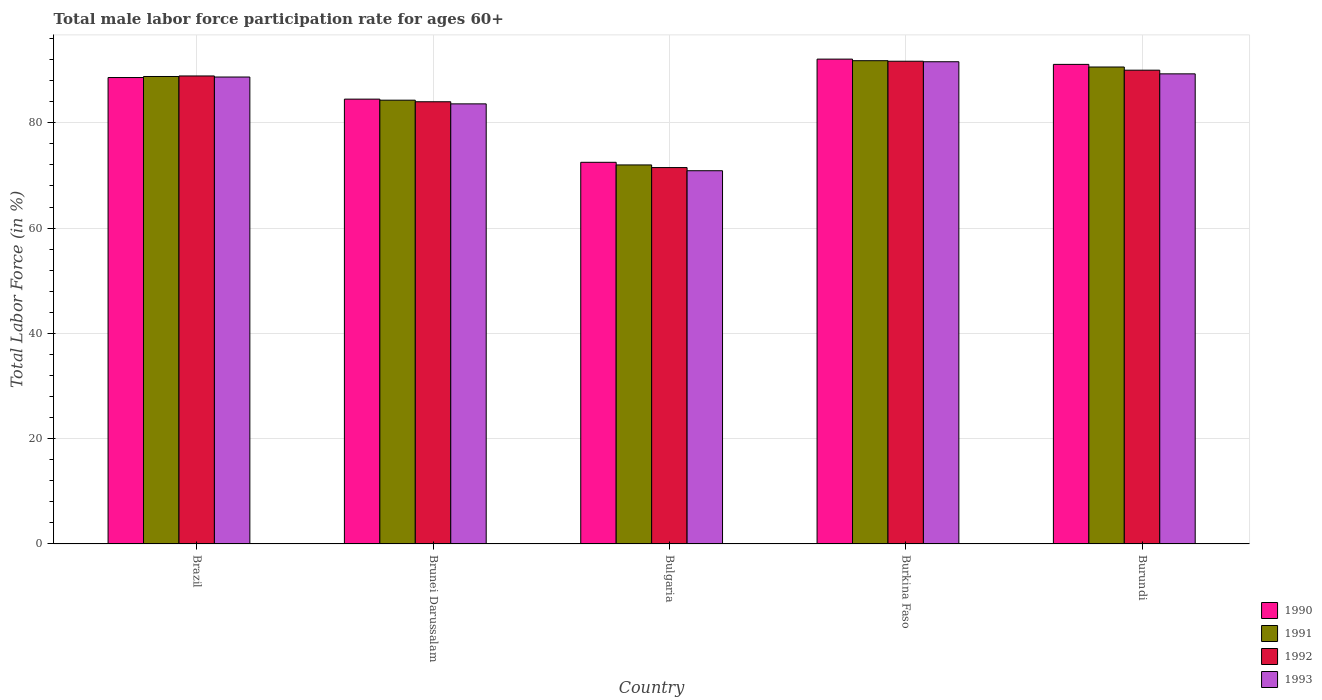How many groups of bars are there?
Make the answer very short. 5. Are the number of bars on each tick of the X-axis equal?
Offer a terse response. Yes. How many bars are there on the 2nd tick from the left?
Provide a succinct answer. 4. How many bars are there on the 2nd tick from the right?
Your response must be concise. 4. What is the label of the 2nd group of bars from the left?
Keep it short and to the point. Brunei Darussalam. In how many cases, is the number of bars for a given country not equal to the number of legend labels?
Your answer should be compact. 0. What is the male labor force participation rate in 1992 in Burundi?
Your response must be concise. 90. Across all countries, what is the maximum male labor force participation rate in 1991?
Provide a succinct answer. 91.8. Across all countries, what is the minimum male labor force participation rate in 1993?
Your answer should be very brief. 70.9. In which country was the male labor force participation rate in 1991 maximum?
Give a very brief answer. Burkina Faso. In which country was the male labor force participation rate in 1990 minimum?
Ensure brevity in your answer.  Bulgaria. What is the total male labor force participation rate in 1990 in the graph?
Give a very brief answer. 428.8. What is the difference between the male labor force participation rate in 1992 in Brazil and that in Bulgaria?
Give a very brief answer. 17.4. What is the difference between the male labor force participation rate in 1991 in Bulgaria and the male labor force participation rate in 1993 in Burkina Faso?
Your answer should be compact. -19.6. What is the average male labor force participation rate in 1991 per country?
Make the answer very short. 85.5. What is the difference between the male labor force participation rate of/in 1991 and male labor force participation rate of/in 1993 in Brunei Darussalam?
Make the answer very short. 0.7. In how many countries, is the male labor force participation rate in 1993 greater than 88 %?
Your response must be concise. 3. What is the ratio of the male labor force participation rate in 1993 in Bulgaria to that in Burkina Faso?
Make the answer very short. 0.77. Is the male labor force participation rate in 1993 in Brunei Darussalam less than that in Burundi?
Your answer should be very brief. Yes. Is the difference between the male labor force participation rate in 1991 in Burkina Faso and Burundi greater than the difference between the male labor force participation rate in 1993 in Burkina Faso and Burundi?
Ensure brevity in your answer.  No. What is the difference between the highest and the second highest male labor force participation rate in 1991?
Provide a succinct answer. -1.8. What is the difference between the highest and the lowest male labor force participation rate in 1993?
Make the answer very short. 20.7. In how many countries, is the male labor force participation rate in 1992 greater than the average male labor force participation rate in 1992 taken over all countries?
Your answer should be compact. 3. Is it the case that in every country, the sum of the male labor force participation rate in 1993 and male labor force participation rate in 1990 is greater than the sum of male labor force participation rate in 1991 and male labor force participation rate in 1992?
Ensure brevity in your answer.  No. What does the 1st bar from the left in Burkina Faso represents?
Offer a terse response. 1990. Does the graph contain grids?
Make the answer very short. Yes. How many legend labels are there?
Ensure brevity in your answer.  4. How are the legend labels stacked?
Offer a very short reply. Vertical. What is the title of the graph?
Offer a very short reply. Total male labor force participation rate for ages 60+. What is the label or title of the Y-axis?
Give a very brief answer. Total Labor Force (in %). What is the Total Labor Force (in %) in 1990 in Brazil?
Your answer should be compact. 88.6. What is the Total Labor Force (in %) in 1991 in Brazil?
Your answer should be very brief. 88.8. What is the Total Labor Force (in %) of 1992 in Brazil?
Your answer should be very brief. 88.9. What is the Total Labor Force (in %) in 1993 in Brazil?
Ensure brevity in your answer.  88.7. What is the Total Labor Force (in %) in 1990 in Brunei Darussalam?
Provide a short and direct response. 84.5. What is the Total Labor Force (in %) of 1991 in Brunei Darussalam?
Provide a succinct answer. 84.3. What is the Total Labor Force (in %) in 1993 in Brunei Darussalam?
Make the answer very short. 83.6. What is the Total Labor Force (in %) of 1990 in Bulgaria?
Your answer should be very brief. 72.5. What is the Total Labor Force (in %) of 1991 in Bulgaria?
Your answer should be very brief. 72. What is the Total Labor Force (in %) of 1992 in Bulgaria?
Make the answer very short. 71.5. What is the Total Labor Force (in %) of 1993 in Bulgaria?
Your answer should be very brief. 70.9. What is the Total Labor Force (in %) in 1990 in Burkina Faso?
Your response must be concise. 92.1. What is the Total Labor Force (in %) in 1991 in Burkina Faso?
Offer a very short reply. 91.8. What is the Total Labor Force (in %) of 1992 in Burkina Faso?
Make the answer very short. 91.7. What is the Total Labor Force (in %) in 1993 in Burkina Faso?
Ensure brevity in your answer.  91.6. What is the Total Labor Force (in %) in 1990 in Burundi?
Make the answer very short. 91.1. What is the Total Labor Force (in %) in 1991 in Burundi?
Your answer should be very brief. 90.6. What is the Total Labor Force (in %) of 1992 in Burundi?
Give a very brief answer. 90. What is the Total Labor Force (in %) in 1993 in Burundi?
Provide a short and direct response. 89.3. Across all countries, what is the maximum Total Labor Force (in %) in 1990?
Offer a terse response. 92.1. Across all countries, what is the maximum Total Labor Force (in %) in 1991?
Your answer should be very brief. 91.8. Across all countries, what is the maximum Total Labor Force (in %) in 1992?
Provide a short and direct response. 91.7. Across all countries, what is the maximum Total Labor Force (in %) of 1993?
Give a very brief answer. 91.6. Across all countries, what is the minimum Total Labor Force (in %) in 1990?
Provide a succinct answer. 72.5. Across all countries, what is the minimum Total Labor Force (in %) in 1992?
Offer a terse response. 71.5. Across all countries, what is the minimum Total Labor Force (in %) of 1993?
Offer a terse response. 70.9. What is the total Total Labor Force (in %) in 1990 in the graph?
Your answer should be compact. 428.8. What is the total Total Labor Force (in %) of 1991 in the graph?
Make the answer very short. 427.5. What is the total Total Labor Force (in %) in 1992 in the graph?
Your answer should be compact. 426.1. What is the total Total Labor Force (in %) in 1993 in the graph?
Your answer should be compact. 424.1. What is the difference between the Total Labor Force (in %) in 1990 in Brazil and that in Brunei Darussalam?
Offer a very short reply. 4.1. What is the difference between the Total Labor Force (in %) of 1992 in Brazil and that in Brunei Darussalam?
Offer a terse response. 4.9. What is the difference between the Total Labor Force (in %) in 1991 in Brazil and that in Bulgaria?
Ensure brevity in your answer.  16.8. What is the difference between the Total Labor Force (in %) in 1992 in Brazil and that in Bulgaria?
Keep it short and to the point. 17.4. What is the difference between the Total Labor Force (in %) in 1990 in Brazil and that in Burundi?
Your response must be concise. -2.5. What is the difference between the Total Labor Force (in %) in 1991 in Brazil and that in Burundi?
Offer a very short reply. -1.8. What is the difference between the Total Labor Force (in %) of 1992 in Brazil and that in Burundi?
Provide a succinct answer. -1.1. What is the difference between the Total Labor Force (in %) in 1993 in Brazil and that in Burundi?
Offer a terse response. -0.6. What is the difference between the Total Labor Force (in %) of 1992 in Brunei Darussalam and that in Bulgaria?
Offer a terse response. 12.5. What is the difference between the Total Labor Force (in %) in 1992 in Brunei Darussalam and that in Burundi?
Your answer should be compact. -6. What is the difference between the Total Labor Force (in %) of 1990 in Bulgaria and that in Burkina Faso?
Keep it short and to the point. -19.6. What is the difference between the Total Labor Force (in %) of 1991 in Bulgaria and that in Burkina Faso?
Your answer should be compact. -19.8. What is the difference between the Total Labor Force (in %) in 1992 in Bulgaria and that in Burkina Faso?
Your response must be concise. -20.2. What is the difference between the Total Labor Force (in %) of 1993 in Bulgaria and that in Burkina Faso?
Your answer should be compact. -20.7. What is the difference between the Total Labor Force (in %) in 1990 in Bulgaria and that in Burundi?
Your answer should be very brief. -18.6. What is the difference between the Total Labor Force (in %) in 1991 in Bulgaria and that in Burundi?
Offer a very short reply. -18.6. What is the difference between the Total Labor Force (in %) in 1992 in Bulgaria and that in Burundi?
Offer a terse response. -18.5. What is the difference between the Total Labor Force (in %) of 1993 in Bulgaria and that in Burundi?
Your response must be concise. -18.4. What is the difference between the Total Labor Force (in %) of 1990 in Burkina Faso and that in Burundi?
Your response must be concise. 1. What is the difference between the Total Labor Force (in %) of 1991 in Burkina Faso and that in Burundi?
Your response must be concise. 1.2. What is the difference between the Total Labor Force (in %) in 1990 in Brazil and the Total Labor Force (in %) in 1993 in Brunei Darussalam?
Make the answer very short. 5. What is the difference between the Total Labor Force (in %) in 1991 in Brazil and the Total Labor Force (in %) in 1992 in Brunei Darussalam?
Offer a very short reply. 4.8. What is the difference between the Total Labor Force (in %) in 1991 in Brazil and the Total Labor Force (in %) in 1993 in Brunei Darussalam?
Make the answer very short. 5.2. What is the difference between the Total Labor Force (in %) in 1991 in Brazil and the Total Labor Force (in %) in 1992 in Bulgaria?
Your response must be concise. 17.3. What is the difference between the Total Labor Force (in %) in 1990 in Brazil and the Total Labor Force (in %) in 1993 in Burkina Faso?
Ensure brevity in your answer.  -3. What is the difference between the Total Labor Force (in %) of 1992 in Brazil and the Total Labor Force (in %) of 1993 in Burkina Faso?
Make the answer very short. -2.7. What is the difference between the Total Labor Force (in %) of 1990 in Brazil and the Total Labor Force (in %) of 1991 in Burundi?
Your answer should be compact. -2. What is the difference between the Total Labor Force (in %) in 1992 in Brazil and the Total Labor Force (in %) in 1993 in Burundi?
Offer a very short reply. -0.4. What is the difference between the Total Labor Force (in %) in 1990 in Brunei Darussalam and the Total Labor Force (in %) in 1991 in Bulgaria?
Make the answer very short. 12.5. What is the difference between the Total Labor Force (in %) in 1990 in Brunei Darussalam and the Total Labor Force (in %) in 1993 in Bulgaria?
Make the answer very short. 13.6. What is the difference between the Total Labor Force (in %) of 1991 in Brunei Darussalam and the Total Labor Force (in %) of 1993 in Bulgaria?
Provide a succinct answer. 13.4. What is the difference between the Total Labor Force (in %) in 1990 in Brunei Darussalam and the Total Labor Force (in %) in 1991 in Burkina Faso?
Your answer should be compact. -7.3. What is the difference between the Total Labor Force (in %) of 1991 in Brunei Darussalam and the Total Labor Force (in %) of 1992 in Burkina Faso?
Make the answer very short. -7.4. What is the difference between the Total Labor Force (in %) of 1991 in Brunei Darussalam and the Total Labor Force (in %) of 1993 in Burkina Faso?
Provide a short and direct response. -7.3. What is the difference between the Total Labor Force (in %) in 1992 in Brunei Darussalam and the Total Labor Force (in %) in 1993 in Burkina Faso?
Provide a short and direct response. -7.6. What is the difference between the Total Labor Force (in %) in 1990 in Brunei Darussalam and the Total Labor Force (in %) in 1991 in Burundi?
Ensure brevity in your answer.  -6.1. What is the difference between the Total Labor Force (in %) in 1990 in Brunei Darussalam and the Total Labor Force (in %) in 1993 in Burundi?
Give a very brief answer. -4.8. What is the difference between the Total Labor Force (in %) of 1991 in Brunei Darussalam and the Total Labor Force (in %) of 1992 in Burundi?
Give a very brief answer. -5.7. What is the difference between the Total Labor Force (in %) of 1991 in Brunei Darussalam and the Total Labor Force (in %) of 1993 in Burundi?
Your answer should be very brief. -5. What is the difference between the Total Labor Force (in %) in 1992 in Brunei Darussalam and the Total Labor Force (in %) in 1993 in Burundi?
Keep it short and to the point. -5.3. What is the difference between the Total Labor Force (in %) of 1990 in Bulgaria and the Total Labor Force (in %) of 1991 in Burkina Faso?
Give a very brief answer. -19.3. What is the difference between the Total Labor Force (in %) of 1990 in Bulgaria and the Total Labor Force (in %) of 1992 in Burkina Faso?
Offer a very short reply. -19.2. What is the difference between the Total Labor Force (in %) in 1990 in Bulgaria and the Total Labor Force (in %) in 1993 in Burkina Faso?
Your answer should be compact. -19.1. What is the difference between the Total Labor Force (in %) of 1991 in Bulgaria and the Total Labor Force (in %) of 1992 in Burkina Faso?
Your answer should be very brief. -19.7. What is the difference between the Total Labor Force (in %) of 1991 in Bulgaria and the Total Labor Force (in %) of 1993 in Burkina Faso?
Ensure brevity in your answer.  -19.6. What is the difference between the Total Labor Force (in %) in 1992 in Bulgaria and the Total Labor Force (in %) in 1993 in Burkina Faso?
Make the answer very short. -20.1. What is the difference between the Total Labor Force (in %) of 1990 in Bulgaria and the Total Labor Force (in %) of 1991 in Burundi?
Provide a short and direct response. -18.1. What is the difference between the Total Labor Force (in %) in 1990 in Bulgaria and the Total Labor Force (in %) in 1992 in Burundi?
Your answer should be very brief. -17.5. What is the difference between the Total Labor Force (in %) in 1990 in Bulgaria and the Total Labor Force (in %) in 1993 in Burundi?
Offer a terse response. -16.8. What is the difference between the Total Labor Force (in %) in 1991 in Bulgaria and the Total Labor Force (in %) in 1992 in Burundi?
Your response must be concise. -18. What is the difference between the Total Labor Force (in %) in 1991 in Bulgaria and the Total Labor Force (in %) in 1993 in Burundi?
Keep it short and to the point. -17.3. What is the difference between the Total Labor Force (in %) in 1992 in Bulgaria and the Total Labor Force (in %) in 1993 in Burundi?
Ensure brevity in your answer.  -17.8. What is the difference between the Total Labor Force (in %) in 1990 in Burkina Faso and the Total Labor Force (in %) in 1991 in Burundi?
Offer a very short reply. 1.5. What is the difference between the Total Labor Force (in %) of 1990 in Burkina Faso and the Total Labor Force (in %) of 1993 in Burundi?
Make the answer very short. 2.8. What is the difference between the Total Labor Force (in %) of 1992 in Burkina Faso and the Total Labor Force (in %) of 1993 in Burundi?
Your answer should be very brief. 2.4. What is the average Total Labor Force (in %) of 1990 per country?
Ensure brevity in your answer.  85.76. What is the average Total Labor Force (in %) of 1991 per country?
Offer a terse response. 85.5. What is the average Total Labor Force (in %) of 1992 per country?
Provide a short and direct response. 85.22. What is the average Total Labor Force (in %) of 1993 per country?
Provide a succinct answer. 84.82. What is the difference between the Total Labor Force (in %) in 1990 and Total Labor Force (in %) in 1991 in Brazil?
Give a very brief answer. -0.2. What is the difference between the Total Labor Force (in %) of 1990 and Total Labor Force (in %) of 1993 in Brazil?
Keep it short and to the point. -0.1. What is the difference between the Total Labor Force (in %) in 1992 and Total Labor Force (in %) in 1993 in Brazil?
Make the answer very short. 0.2. What is the difference between the Total Labor Force (in %) of 1990 and Total Labor Force (in %) of 1993 in Brunei Darussalam?
Offer a very short reply. 0.9. What is the difference between the Total Labor Force (in %) in 1992 and Total Labor Force (in %) in 1993 in Brunei Darussalam?
Provide a short and direct response. 0.4. What is the difference between the Total Labor Force (in %) of 1990 and Total Labor Force (in %) of 1993 in Bulgaria?
Offer a very short reply. 1.6. What is the difference between the Total Labor Force (in %) in 1990 and Total Labor Force (in %) in 1993 in Burkina Faso?
Offer a very short reply. 0.5. What is the difference between the Total Labor Force (in %) in 1991 and Total Labor Force (in %) in 1992 in Burkina Faso?
Your answer should be compact. 0.1. What is the difference between the Total Labor Force (in %) of 1991 and Total Labor Force (in %) of 1993 in Burkina Faso?
Your answer should be very brief. 0.2. What is the difference between the Total Labor Force (in %) in 1991 and Total Labor Force (in %) in 1993 in Burundi?
Ensure brevity in your answer.  1.3. What is the difference between the Total Labor Force (in %) of 1992 and Total Labor Force (in %) of 1993 in Burundi?
Make the answer very short. 0.7. What is the ratio of the Total Labor Force (in %) of 1990 in Brazil to that in Brunei Darussalam?
Give a very brief answer. 1.05. What is the ratio of the Total Labor Force (in %) in 1991 in Brazil to that in Brunei Darussalam?
Give a very brief answer. 1.05. What is the ratio of the Total Labor Force (in %) in 1992 in Brazil to that in Brunei Darussalam?
Your answer should be compact. 1.06. What is the ratio of the Total Labor Force (in %) in 1993 in Brazil to that in Brunei Darussalam?
Your answer should be very brief. 1.06. What is the ratio of the Total Labor Force (in %) of 1990 in Brazil to that in Bulgaria?
Offer a terse response. 1.22. What is the ratio of the Total Labor Force (in %) of 1991 in Brazil to that in Bulgaria?
Keep it short and to the point. 1.23. What is the ratio of the Total Labor Force (in %) of 1992 in Brazil to that in Bulgaria?
Provide a short and direct response. 1.24. What is the ratio of the Total Labor Force (in %) in 1993 in Brazil to that in Bulgaria?
Ensure brevity in your answer.  1.25. What is the ratio of the Total Labor Force (in %) of 1991 in Brazil to that in Burkina Faso?
Ensure brevity in your answer.  0.97. What is the ratio of the Total Labor Force (in %) of 1992 in Brazil to that in Burkina Faso?
Keep it short and to the point. 0.97. What is the ratio of the Total Labor Force (in %) in 1993 in Brazil to that in Burkina Faso?
Your response must be concise. 0.97. What is the ratio of the Total Labor Force (in %) in 1990 in Brazil to that in Burundi?
Ensure brevity in your answer.  0.97. What is the ratio of the Total Labor Force (in %) of 1991 in Brazil to that in Burundi?
Offer a very short reply. 0.98. What is the ratio of the Total Labor Force (in %) of 1992 in Brazil to that in Burundi?
Offer a terse response. 0.99. What is the ratio of the Total Labor Force (in %) of 1993 in Brazil to that in Burundi?
Offer a terse response. 0.99. What is the ratio of the Total Labor Force (in %) in 1990 in Brunei Darussalam to that in Bulgaria?
Keep it short and to the point. 1.17. What is the ratio of the Total Labor Force (in %) of 1991 in Brunei Darussalam to that in Bulgaria?
Keep it short and to the point. 1.17. What is the ratio of the Total Labor Force (in %) in 1992 in Brunei Darussalam to that in Bulgaria?
Your answer should be compact. 1.17. What is the ratio of the Total Labor Force (in %) in 1993 in Brunei Darussalam to that in Bulgaria?
Your answer should be very brief. 1.18. What is the ratio of the Total Labor Force (in %) in 1990 in Brunei Darussalam to that in Burkina Faso?
Offer a terse response. 0.92. What is the ratio of the Total Labor Force (in %) of 1991 in Brunei Darussalam to that in Burkina Faso?
Your answer should be very brief. 0.92. What is the ratio of the Total Labor Force (in %) in 1992 in Brunei Darussalam to that in Burkina Faso?
Provide a succinct answer. 0.92. What is the ratio of the Total Labor Force (in %) in 1993 in Brunei Darussalam to that in Burkina Faso?
Offer a very short reply. 0.91. What is the ratio of the Total Labor Force (in %) in 1990 in Brunei Darussalam to that in Burundi?
Your answer should be very brief. 0.93. What is the ratio of the Total Labor Force (in %) of 1991 in Brunei Darussalam to that in Burundi?
Offer a terse response. 0.93. What is the ratio of the Total Labor Force (in %) of 1993 in Brunei Darussalam to that in Burundi?
Make the answer very short. 0.94. What is the ratio of the Total Labor Force (in %) of 1990 in Bulgaria to that in Burkina Faso?
Make the answer very short. 0.79. What is the ratio of the Total Labor Force (in %) of 1991 in Bulgaria to that in Burkina Faso?
Offer a terse response. 0.78. What is the ratio of the Total Labor Force (in %) of 1992 in Bulgaria to that in Burkina Faso?
Give a very brief answer. 0.78. What is the ratio of the Total Labor Force (in %) of 1993 in Bulgaria to that in Burkina Faso?
Your answer should be very brief. 0.77. What is the ratio of the Total Labor Force (in %) of 1990 in Bulgaria to that in Burundi?
Provide a succinct answer. 0.8. What is the ratio of the Total Labor Force (in %) of 1991 in Bulgaria to that in Burundi?
Offer a terse response. 0.79. What is the ratio of the Total Labor Force (in %) in 1992 in Bulgaria to that in Burundi?
Offer a very short reply. 0.79. What is the ratio of the Total Labor Force (in %) of 1993 in Bulgaria to that in Burundi?
Your answer should be very brief. 0.79. What is the ratio of the Total Labor Force (in %) of 1991 in Burkina Faso to that in Burundi?
Your answer should be very brief. 1.01. What is the ratio of the Total Labor Force (in %) of 1992 in Burkina Faso to that in Burundi?
Provide a succinct answer. 1.02. What is the ratio of the Total Labor Force (in %) of 1993 in Burkina Faso to that in Burundi?
Offer a very short reply. 1.03. What is the difference between the highest and the second highest Total Labor Force (in %) in 1991?
Provide a succinct answer. 1.2. What is the difference between the highest and the second highest Total Labor Force (in %) of 1992?
Keep it short and to the point. 1.7. What is the difference between the highest and the lowest Total Labor Force (in %) in 1990?
Give a very brief answer. 19.6. What is the difference between the highest and the lowest Total Labor Force (in %) of 1991?
Your response must be concise. 19.8. What is the difference between the highest and the lowest Total Labor Force (in %) in 1992?
Offer a very short reply. 20.2. What is the difference between the highest and the lowest Total Labor Force (in %) of 1993?
Give a very brief answer. 20.7. 